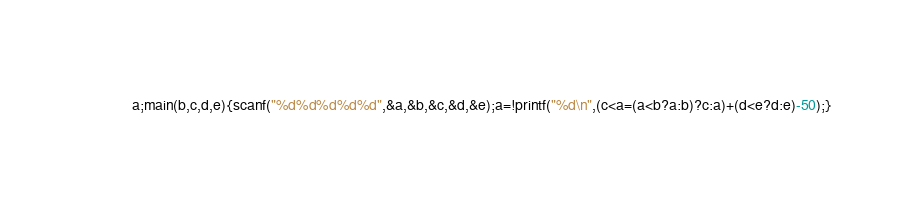Convert code to text. <code><loc_0><loc_0><loc_500><loc_500><_C_>a;main(b,c,d,e){scanf("%d%d%d%d%d",&a,&b,&c,&d,&e);a=!printf("%d\n",(c<a=(a<b?a:b)?c:a)+(d<e?d:e)-50);}</code> 